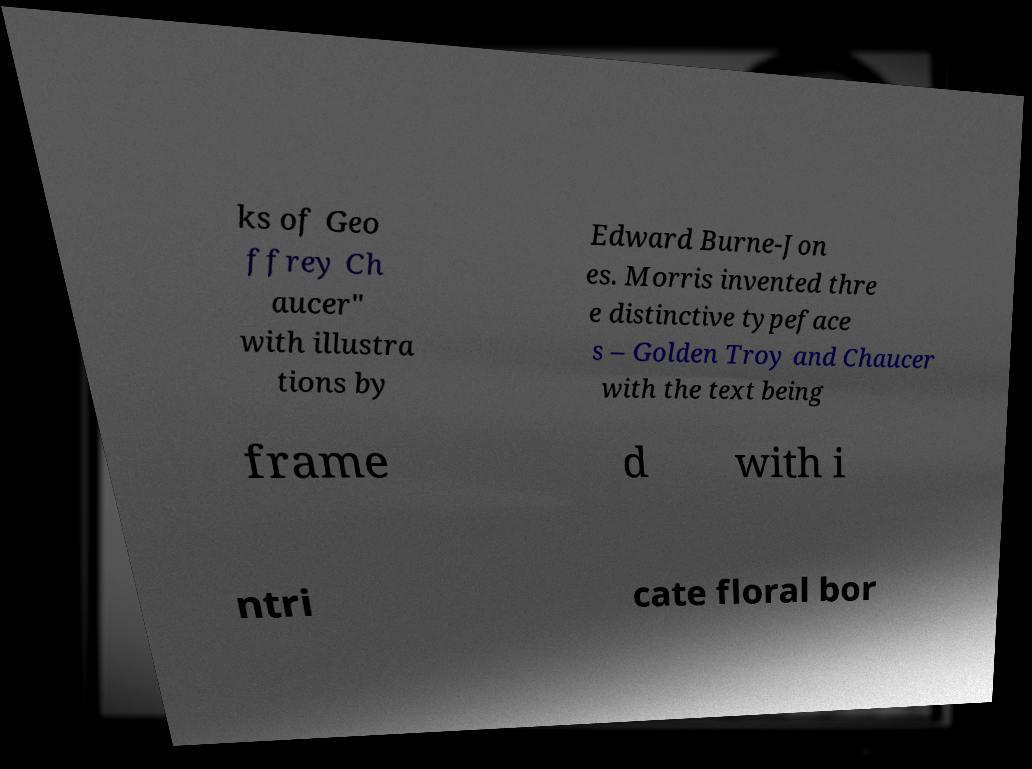For documentation purposes, I need the text within this image transcribed. Could you provide that? ks of Geo ffrey Ch aucer" with illustra tions by Edward Burne-Jon es. Morris invented thre e distinctive typeface s – Golden Troy and Chaucer with the text being frame d with i ntri cate floral bor 